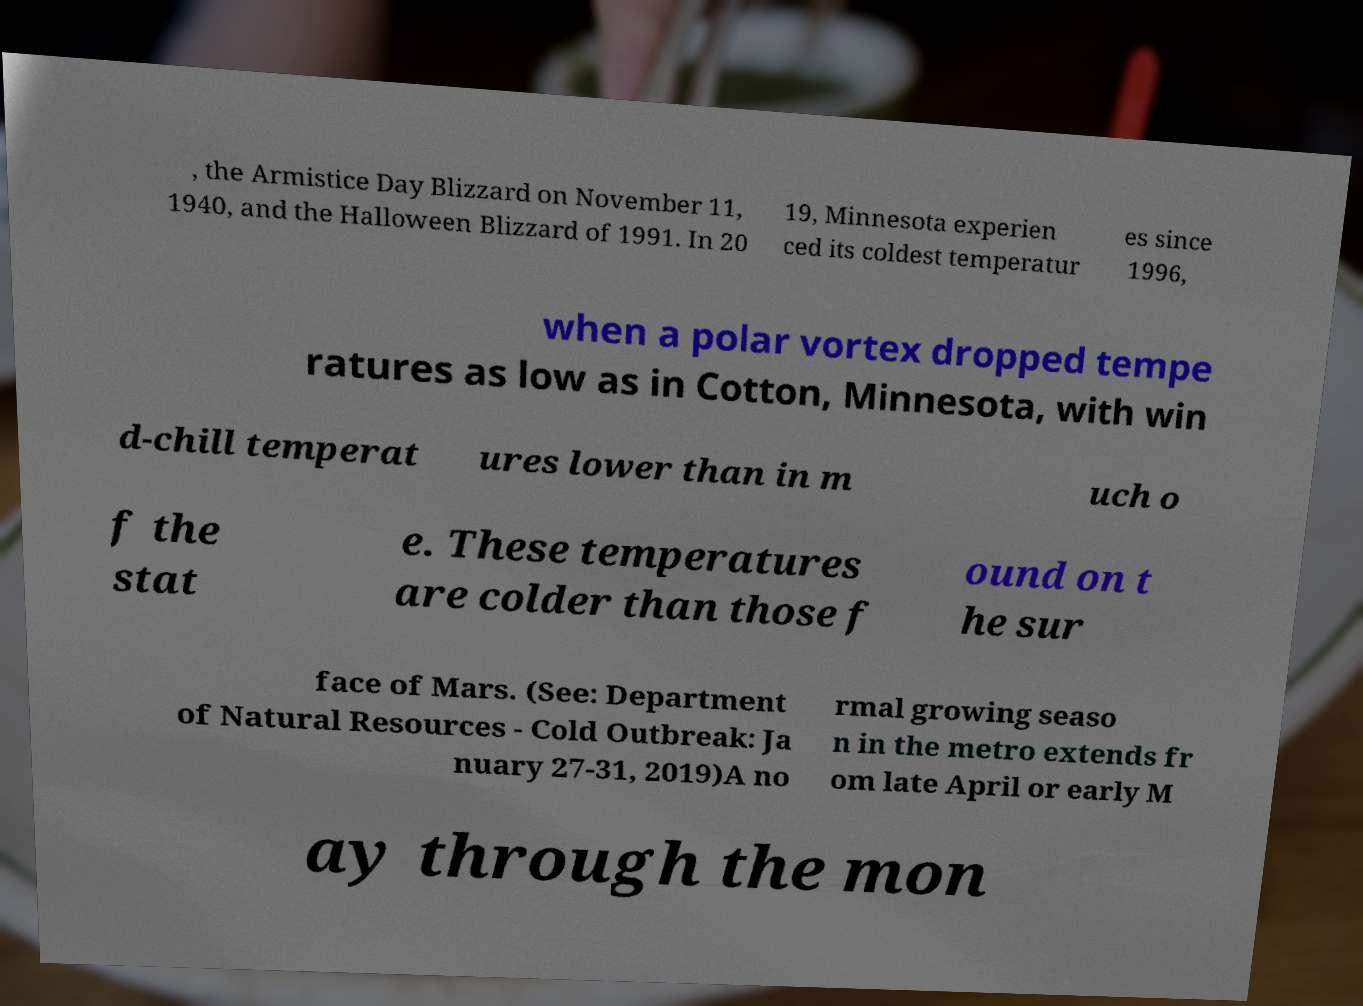Please identify and transcribe the text found in this image. , the Armistice Day Blizzard on November 11, 1940, and the Halloween Blizzard of 1991. In 20 19, Minnesota experien ced its coldest temperatur es since 1996, when a polar vortex dropped tempe ratures as low as in Cotton, Minnesota, with win d-chill temperat ures lower than in m uch o f the stat e. These temperatures are colder than those f ound on t he sur face of Mars. (See: Department of Natural Resources - Cold Outbreak: Ja nuary 27-31, 2019)A no rmal growing seaso n in the metro extends fr om late April or early M ay through the mon 